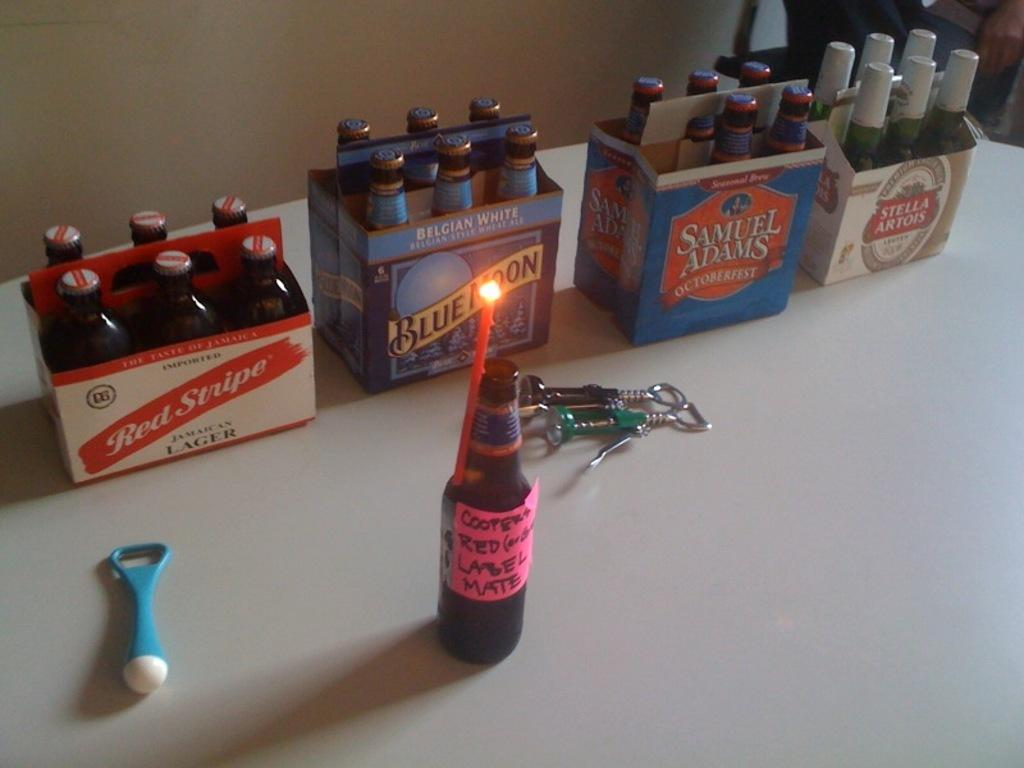Provide a one-sentence caption for the provided image. A line of six packs of beer on a table and a single bottle labeled red label mate. 